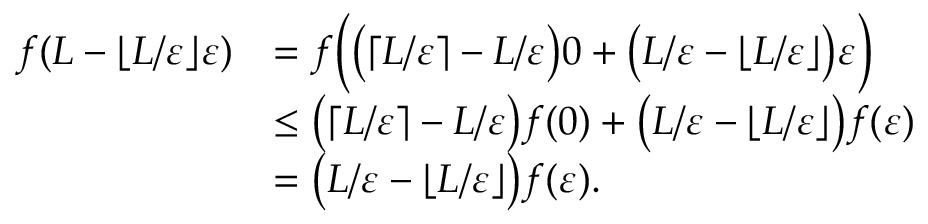<formula> <loc_0><loc_0><loc_500><loc_500>\begin{array} { r l } { f ( L - \lfloor { L / \varepsilon } \rfloor \varepsilon ) } & { = f \left ( \left ( \lceil L / \varepsilon \rceil - L / \varepsilon \right ) 0 + \left ( L / \varepsilon - \lfloor { L / \varepsilon } \rfloor \right ) \varepsilon \right ) } \\ & { \leq \left ( \lceil L / \varepsilon \rceil - L / \varepsilon \right ) f ( 0 ) + \left ( L / \varepsilon - \lfloor { L / \varepsilon } \rfloor \right ) f ( \varepsilon ) } \\ & { = \left ( L / \varepsilon - \lfloor { L / \varepsilon } \rfloor \right ) f ( \varepsilon ) . } \end{array}</formula> 